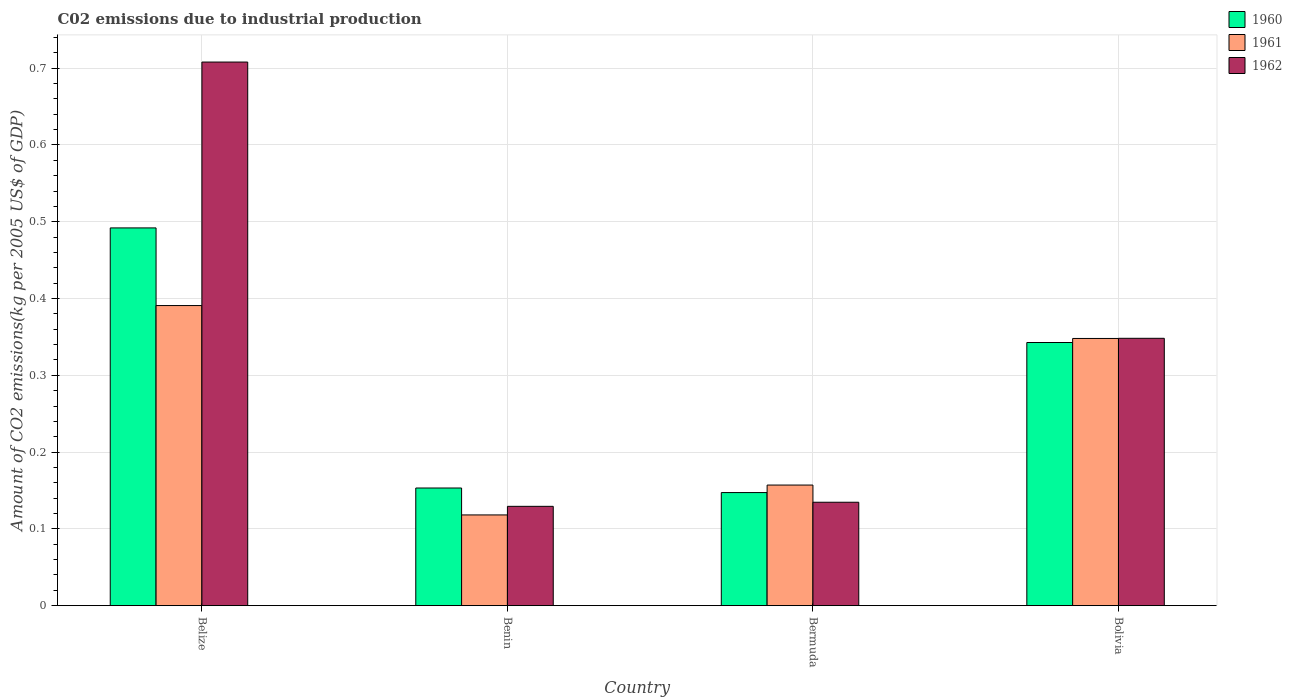How many different coloured bars are there?
Your answer should be compact. 3. How many groups of bars are there?
Your answer should be very brief. 4. Are the number of bars per tick equal to the number of legend labels?
Give a very brief answer. Yes. Are the number of bars on each tick of the X-axis equal?
Your response must be concise. Yes. How many bars are there on the 4th tick from the right?
Make the answer very short. 3. What is the label of the 1st group of bars from the left?
Your answer should be compact. Belize. In how many cases, is the number of bars for a given country not equal to the number of legend labels?
Ensure brevity in your answer.  0. What is the amount of CO2 emitted due to industrial production in 1960 in Benin?
Provide a succinct answer. 0.15. Across all countries, what is the maximum amount of CO2 emitted due to industrial production in 1960?
Offer a terse response. 0.49. Across all countries, what is the minimum amount of CO2 emitted due to industrial production in 1960?
Your answer should be compact. 0.15. In which country was the amount of CO2 emitted due to industrial production in 1961 maximum?
Provide a short and direct response. Belize. In which country was the amount of CO2 emitted due to industrial production in 1962 minimum?
Provide a succinct answer. Benin. What is the total amount of CO2 emitted due to industrial production in 1960 in the graph?
Make the answer very short. 1.14. What is the difference between the amount of CO2 emitted due to industrial production in 1960 in Benin and that in Bolivia?
Make the answer very short. -0.19. What is the difference between the amount of CO2 emitted due to industrial production in 1961 in Belize and the amount of CO2 emitted due to industrial production in 1962 in Bolivia?
Give a very brief answer. 0.04. What is the average amount of CO2 emitted due to industrial production in 1961 per country?
Provide a short and direct response. 0.25. What is the difference between the amount of CO2 emitted due to industrial production of/in 1961 and amount of CO2 emitted due to industrial production of/in 1960 in Bermuda?
Your response must be concise. 0.01. In how many countries, is the amount of CO2 emitted due to industrial production in 1961 greater than 0.02 kg?
Ensure brevity in your answer.  4. What is the ratio of the amount of CO2 emitted due to industrial production in 1960 in Belize to that in Bolivia?
Your answer should be compact. 1.44. Is the amount of CO2 emitted due to industrial production in 1962 in Belize less than that in Bermuda?
Ensure brevity in your answer.  No. What is the difference between the highest and the second highest amount of CO2 emitted due to industrial production in 1962?
Make the answer very short. 0.36. What is the difference between the highest and the lowest amount of CO2 emitted due to industrial production in 1960?
Your answer should be very brief. 0.34. In how many countries, is the amount of CO2 emitted due to industrial production in 1962 greater than the average amount of CO2 emitted due to industrial production in 1962 taken over all countries?
Your response must be concise. 2. What does the 3rd bar from the right in Bermuda represents?
Ensure brevity in your answer.  1960. Does the graph contain any zero values?
Offer a very short reply. No. Where does the legend appear in the graph?
Offer a very short reply. Top right. How are the legend labels stacked?
Make the answer very short. Vertical. What is the title of the graph?
Make the answer very short. C02 emissions due to industrial production. What is the label or title of the Y-axis?
Your response must be concise. Amount of CO2 emissions(kg per 2005 US$ of GDP). What is the Amount of CO2 emissions(kg per 2005 US$ of GDP) in 1960 in Belize?
Ensure brevity in your answer.  0.49. What is the Amount of CO2 emissions(kg per 2005 US$ of GDP) of 1961 in Belize?
Keep it short and to the point. 0.39. What is the Amount of CO2 emissions(kg per 2005 US$ of GDP) in 1962 in Belize?
Make the answer very short. 0.71. What is the Amount of CO2 emissions(kg per 2005 US$ of GDP) of 1960 in Benin?
Give a very brief answer. 0.15. What is the Amount of CO2 emissions(kg per 2005 US$ of GDP) in 1961 in Benin?
Your answer should be compact. 0.12. What is the Amount of CO2 emissions(kg per 2005 US$ of GDP) of 1962 in Benin?
Offer a very short reply. 0.13. What is the Amount of CO2 emissions(kg per 2005 US$ of GDP) of 1960 in Bermuda?
Ensure brevity in your answer.  0.15. What is the Amount of CO2 emissions(kg per 2005 US$ of GDP) of 1961 in Bermuda?
Provide a short and direct response. 0.16. What is the Amount of CO2 emissions(kg per 2005 US$ of GDP) in 1962 in Bermuda?
Provide a short and direct response. 0.13. What is the Amount of CO2 emissions(kg per 2005 US$ of GDP) in 1960 in Bolivia?
Give a very brief answer. 0.34. What is the Amount of CO2 emissions(kg per 2005 US$ of GDP) of 1961 in Bolivia?
Your answer should be very brief. 0.35. What is the Amount of CO2 emissions(kg per 2005 US$ of GDP) of 1962 in Bolivia?
Provide a succinct answer. 0.35. Across all countries, what is the maximum Amount of CO2 emissions(kg per 2005 US$ of GDP) in 1960?
Your answer should be very brief. 0.49. Across all countries, what is the maximum Amount of CO2 emissions(kg per 2005 US$ of GDP) of 1961?
Your response must be concise. 0.39. Across all countries, what is the maximum Amount of CO2 emissions(kg per 2005 US$ of GDP) of 1962?
Provide a succinct answer. 0.71. Across all countries, what is the minimum Amount of CO2 emissions(kg per 2005 US$ of GDP) in 1960?
Provide a short and direct response. 0.15. Across all countries, what is the minimum Amount of CO2 emissions(kg per 2005 US$ of GDP) in 1961?
Your answer should be compact. 0.12. Across all countries, what is the minimum Amount of CO2 emissions(kg per 2005 US$ of GDP) in 1962?
Your answer should be very brief. 0.13. What is the total Amount of CO2 emissions(kg per 2005 US$ of GDP) of 1960 in the graph?
Your response must be concise. 1.14. What is the total Amount of CO2 emissions(kg per 2005 US$ of GDP) of 1961 in the graph?
Your response must be concise. 1.01. What is the total Amount of CO2 emissions(kg per 2005 US$ of GDP) of 1962 in the graph?
Your answer should be very brief. 1.32. What is the difference between the Amount of CO2 emissions(kg per 2005 US$ of GDP) in 1960 in Belize and that in Benin?
Offer a terse response. 0.34. What is the difference between the Amount of CO2 emissions(kg per 2005 US$ of GDP) of 1961 in Belize and that in Benin?
Offer a terse response. 0.27. What is the difference between the Amount of CO2 emissions(kg per 2005 US$ of GDP) in 1962 in Belize and that in Benin?
Your response must be concise. 0.58. What is the difference between the Amount of CO2 emissions(kg per 2005 US$ of GDP) in 1960 in Belize and that in Bermuda?
Your answer should be very brief. 0.34. What is the difference between the Amount of CO2 emissions(kg per 2005 US$ of GDP) in 1961 in Belize and that in Bermuda?
Provide a succinct answer. 0.23. What is the difference between the Amount of CO2 emissions(kg per 2005 US$ of GDP) of 1962 in Belize and that in Bermuda?
Your response must be concise. 0.57. What is the difference between the Amount of CO2 emissions(kg per 2005 US$ of GDP) of 1960 in Belize and that in Bolivia?
Give a very brief answer. 0.15. What is the difference between the Amount of CO2 emissions(kg per 2005 US$ of GDP) in 1961 in Belize and that in Bolivia?
Offer a very short reply. 0.04. What is the difference between the Amount of CO2 emissions(kg per 2005 US$ of GDP) of 1962 in Belize and that in Bolivia?
Your answer should be very brief. 0.36. What is the difference between the Amount of CO2 emissions(kg per 2005 US$ of GDP) in 1960 in Benin and that in Bermuda?
Offer a very short reply. 0.01. What is the difference between the Amount of CO2 emissions(kg per 2005 US$ of GDP) of 1961 in Benin and that in Bermuda?
Provide a succinct answer. -0.04. What is the difference between the Amount of CO2 emissions(kg per 2005 US$ of GDP) in 1962 in Benin and that in Bermuda?
Your answer should be very brief. -0.01. What is the difference between the Amount of CO2 emissions(kg per 2005 US$ of GDP) in 1960 in Benin and that in Bolivia?
Keep it short and to the point. -0.19. What is the difference between the Amount of CO2 emissions(kg per 2005 US$ of GDP) of 1961 in Benin and that in Bolivia?
Keep it short and to the point. -0.23. What is the difference between the Amount of CO2 emissions(kg per 2005 US$ of GDP) in 1962 in Benin and that in Bolivia?
Your answer should be very brief. -0.22. What is the difference between the Amount of CO2 emissions(kg per 2005 US$ of GDP) of 1960 in Bermuda and that in Bolivia?
Offer a very short reply. -0.2. What is the difference between the Amount of CO2 emissions(kg per 2005 US$ of GDP) of 1961 in Bermuda and that in Bolivia?
Ensure brevity in your answer.  -0.19. What is the difference between the Amount of CO2 emissions(kg per 2005 US$ of GDP) of 1962 in Bermuda and that in Bolivia?
Your answer should be very brief. -0.21. What is the difference between the Amount of CO2 emissions(kg per 2005 US$ of GDP) of 1960 in Belize and the Amount of CO2 emissions(kg per 2005 US$ of GDP) of 1961 in Benin?
Your answer should be very brief. 0.37. What is the difference between the Amount of CO2 emissions(kg per 2005 US$ of GDP) in 1960 in Belize and the Amount of CO2 emissions(kg per 2005 US$ of GDP) in 1962 in Benin?
Make the answer very short. 0.36. What is the difference between the Amount of CO2 emissions(kg per 2005 US$ of GDP) in 1961 in Belize and the Amount of CO2 emissions(kg per 2005 US$ of GDP) in 1962 in Benin?
Keep it short and to the point. 0.26. What is the difference between the Amount of CO2 emissions(kg per 2005 US$ of GDP) in 1960 in Belize and the Amount of CO2 emissions(kg per 2005 US$ of GDP) in 1961 in Bermuda?
Provide a succinct answer. 0.33. What is the difference between the Amount of CO2 emissions(kg per 2005 US$ of GDP) in 1960 in Belize and the Amount of CO2 emissions(kg per 2005 US$ of GDP) in 1962 in Bermuda?
Offer a terse response. 0.36. What is the difference between the Amount of CO2 emissions(kg per 2005 US$ of GDP) of 1961 in Belize and the Amount of CO2 emissions(kg per 2005 US$ of GDP) of 1962 in Bermuda?
Ensure brevity in your answer.  0.26. What is the difference between the Amount of CO2 emissions(kg per 2005 US$ of GDP) of 1960 in Belize and the Amount of CO2 emissions(kg per 2005 US$ of GDP) of 1961 in Bolivia?
Make the answer very short. 0.14. What is the difference between the Amount of CO2 emissions(kg per 2005 US$ of GDP) of 1960 in Belize and the Amount of CO2 emissions(kg per 2005 US$ of GDP) of 1962 in Bolivia?
Keep it short and to the point. 0.14. What is the difference between the Amount of CO2 emissions(kg per 2005 US$ of GDP) in 1961 in Belize and the Amount of CO2 emissions(kg per 2005 US$ of GDP) in 1962 in Bolivia?
Give a very brief answer. 0.04. What is the difference between the Amount of CO2 emissions(kg per 2005 US$ of GDP) in 1960 in Benin and the Amount of CO2 emissions(kg per 2005 US$ of GDP) in 1961 in Bermuda?
Keep it short and to the point. -0. What is the difference between the Amount of CO2 emissions(kg per 2005 US$ of GDP) of 1960 in Benin and the Amount of CO2 emissions(kg per 2005 US$ of GDP) of 1962 in Bermuda?
Ensure brevity in your answer.  0.02. What is the difference between the Amount of CO2 emissions(kg per 2005 US$ of GDP) of 1961 in Benin and the Amount of CO2 emissions(kg per 2005 US$ of GDP) of 1962 in Bermuda?
Make the answer very short. -0.02. What is the difference between the Amount of CO2 emissions(kg per 2005 US$ of GDP) of 1960 in Benin and the Amount of CO2 emissions(kg per 2005 US$ of GDP) of 1961 in Bolivia?
Your response must be concise. -0.19. What is the difference between the Amount of CO2 emissions(kg per 2005 US$ of GDP) in 1960 in Benin and the Amount of CO2 emissions(kg per 2005 US$ of GDP) in 1962 in Bolivia?
Your answer should be compact. -0.2. What is the difference between the Amount of CO2 emissions(kg per 2005 US$ of GDP) in 1961 in Benin and the Amount of CO2 emissions(kg per 2005 US$ of GDP) in 1962 in Bolivia?
Ensure brevity in your answer.  -0.23. What is the difference between the Amount of CO2 emissions(kg per 2005 US$ of GDP) of 1960 in Bermuda and the Amount of CO2 emissions(kg per 2005 US$ of GDP) of 1961 in Bolivia?
Offer a very short reply. -0.2. What is the difference between the Amount of CO2 emissions(kg per 2005 US$ of GDP) in 1960 in Bermuda and the Amount of CO2 emissions(kg per 2005 US$ of GDP) in 1962 in Bolivia?
Offer a terse response. -0.2. What is the difference between the Amount of CO2 emissions(kg per 2005 US$ of GDP) in 1961 in Bermuda and the Amount of CO2 emissions(kg per 2005 US$ of GDP) in 1962 in Bolivia?
Your answer should be compact. -0.19. What is the average Amount of CO2 emissions(kg per 2005 US$ of GDP) of 1960 per country?
Give a very brief answer. 0.28. What is the average Amount of CO2 emissions(kg per 2005 US$ of GDP) of 1961 per country?
Offer a terse response. 0.25. What is the average Amount of CO2 emissions(kg per 2005 US$ of GDP) of 1962 per country?
Offer a very short reply. 0.33. What is the difference between the Amount of CO2 emissions(kg per 2005 US$ of GDP) in 1960 and Amount of CO2 emissions(kg per 2005 US$ of GDP) in 1961 in Belize?
Provide a succinct answer. 0.1. What is the difference between the Amount of CO2 emissions(kg per 2005 US$ of GDP) of 1960 and Amount of CO2 emissions(kg per 2005 US$ of GDP) of 1962 in Belize?
Ensure brevity in your answer.  -0.22. What is the difference between the Amount of CO2 emissions(kg per 2005 US$ of GDP) in 1961 and Amount of CO2 emissions(kg per 2005 US$ of GDP) in 1962 in Belize?
Keep it short and to the point. -0.32. What is the difference between the Amount of CO2 emissions(kg per 2005 US$ of GDP) of 1960 and Amount of CO2 emissions(kg per 2005 US$ of GDP) of 1961 in Benin?
Offer a very short reply. 0.04. What is the difference between the Amount of CO2 emissions(kg per 2005 US$ of GDP) in 1960 and Amount of CO2 emissions(kg per 2005 US$ of GDP) in 1962 in Benin?
Offer a terse response. 0.02. What is the difference between the Amount of CO2 emissions(kg per 2005 US$ of GDP) in 1961 and Amount of CO2 emissions(kg per 2005 US$ of GDP) in 1962 in Benin?
Offer a very short reply. -0.01. What is the difference between the Amount of CO2 emissions(kg per 2005 US$ of GDP) in 1960 and Amount of CO2 emissions(kg per 2005 US$ of GDP) in 1961 in Bermuda?
Offer a very short reply. -0.01. What is the difference between the Amount of CO2 emissions(kg per 2005 US$ of GDP) in 1960 and Amount of CO2 emissions(kg per 2005 US$ of GDP) in 1962 in Bermuda?
Your answer should be compact. 0.01. What is the difference between the Amount of CO2 emissions(kg per 2005 US$ of GDP) in 1961 and Amount of CO2 emissions(kg per 2005 US$ of GDP) in 1962 in Bermuda?
Your answer should be compact. 0.02. What is the difference between the Amount of CO2 emissions(kg per 2005 US$ of GDP) in 1960 and Amount of CO2 emissions(kg per 2005 US$ of GDP) in 1961 in Bolivia?
Your response must be concise. -0.01. What is the difference between the Amount of CO2 emissions(kg per 2005 US$ of GDP) of 1960 and Amount of CO2 emissions(kg per 2005 US$ of GDP) of 1962 in Bolivia?
Make the answer very short. -0.01. What is the difference between the Amount of CO2 emissions(kg per 2005 US$ of GDP) in 1961 and Amount of CO2 emissions(kg per 2005 US$ of GDP) in 1962 in Bolivia?
Keep it short and to the point. -0. What is the ratio of the Amount of CO2 emissions(kg per 2005 US$ of GDP) of 1960 in Belize to that in Benin?
Your answer should be very brief. 3.21. What is the ratio of the Amount of CO2 emissions(kg per 2005 US$ of GDP) of 1961 in Belize to that in Benin?
Make the answer very short. 3.31. What is the ratio of the Amount of CO2 emissions(kg per 2005 US$ of GDP) in 1962 in Belize to that in Benin?
Ensure brevity in your answer.  5.47. What is the ratio of the Amount of CO2 emissions(kg per 2005 US$ of GDP) of 1960 in Belize to that in Bermuda?
Your answer should be compact. 3.34. What is the ratio of the Amount of CO2 emissions(kg per 2005 US$ of GDP) in 1961 in Belize to that in Bermuda?
Give a very brief answer. 2.49. What is the ratio of the Amount of CO2 emissions(kg per 2005 US$ of GDP) in 1962 in Belize to that in Bermuda?
Give a very brief answer. 5.26. What is the ratio of the Amount of CO2 emissions(kg per 2005 US$ of GDP) in 1960 in Belize to that in Bolivia?
Give a very brief answer. 1.44. What is the ratio of the Amount of CO2 emissions(kg per 2005 US$ of GDP) of 1961 in Belize to that in Bolivia?
Offer a very short reply. 1.12. What is the ratio of the Amount of CO2 emissions(kg per 2005 US$ of GDP) of 1962 in Belize to that in Bolivia?
Give a very brief answer. 2.03. What is the ratio of the Amount of CO2 emissions(kg per 2005 US$ of GDP) of 1960 in Benin to that in Bermuda?
Your answer should be compact. 1.04. What is the ratio of the Amount of CO2 emissions(kg per 2005 US$ of GDP) of 1961 in Benin to that in Bermuda?
Offer a very short reply. 0.75. What is the ratio of the Amount of CO2 emissions(kg per 2005 US$ of GDP) in 1962 in Benin to that in Bermuda?
Ensure brevity in your answer.  0.96. What is the ratio of the Amount of CO2 emissions(kg per 2005 US$ of GDP) in 1960 in Benin to that in Bolivia?
Provide a succinct answer. 0.45. What is the ratio of the Amount of CO2 emissions(kg per 2005 US$ of GDP) in 1961 in Benin to that in Bolivia?
Provide a succinct answer. 0.34. What is the ratio of the Amount of CO2 emissions(kg per 2005 US$ of GDP) in 1962 in Benin to that in Bolivia?
Keep it short and to the point. 0.37. What is the ratio of the Amount of CO2 emissions(kg per 2005 US$ of GDP) of 1960 in Bermuda to that in Bolivia?
Your answer should be very brief. 0.43. What is the ratio of the Amount of CO2 emissions(kg per 2005 US$ of GDP) in 1961 in Bermuda to that in Bolivia?
Provide a succinct answer. 0.45. What is the ratio of the Amount of CO2 emissions(kg per 2005 US$ of GDP) of 1962 in Bermuda to that in Bolivia?
Keep it short and to the point. 0.39. What is the difference between the highest and the second highest Amount of CO2 emissions(kg per 2005 US$ of GDP) in 1960?
Ensure brevity in your answer.  0.15. What is the difference between the highest and the second highest Amount of CO2 emissions(kg per 2005 US$ of GDP) in 1961?
Make the answer very short. 0.04. What is the difference between the highest and the second highest Amount of CO2 emissions(kg per 2005 US$ of GDP) of 1962?
Offer a terse response. 0.36. What is the difference between the highest and the lowest Amount of CO2 emissions(kg per 2005 US$ of GDP) in 1960?
Keep it short and to the point. 0.34. What is the difference between the highest and the lowest Amount of CO2 emissions(kg per 2005 US$ of GDP) in 1961?
Offer a terse response. 0.27. What is the difference between the highest and the lowest Amount of CO2 emissions(kg per 2005 US$ of GDP) in 1962?
Your answer should be compact. 0.58. 